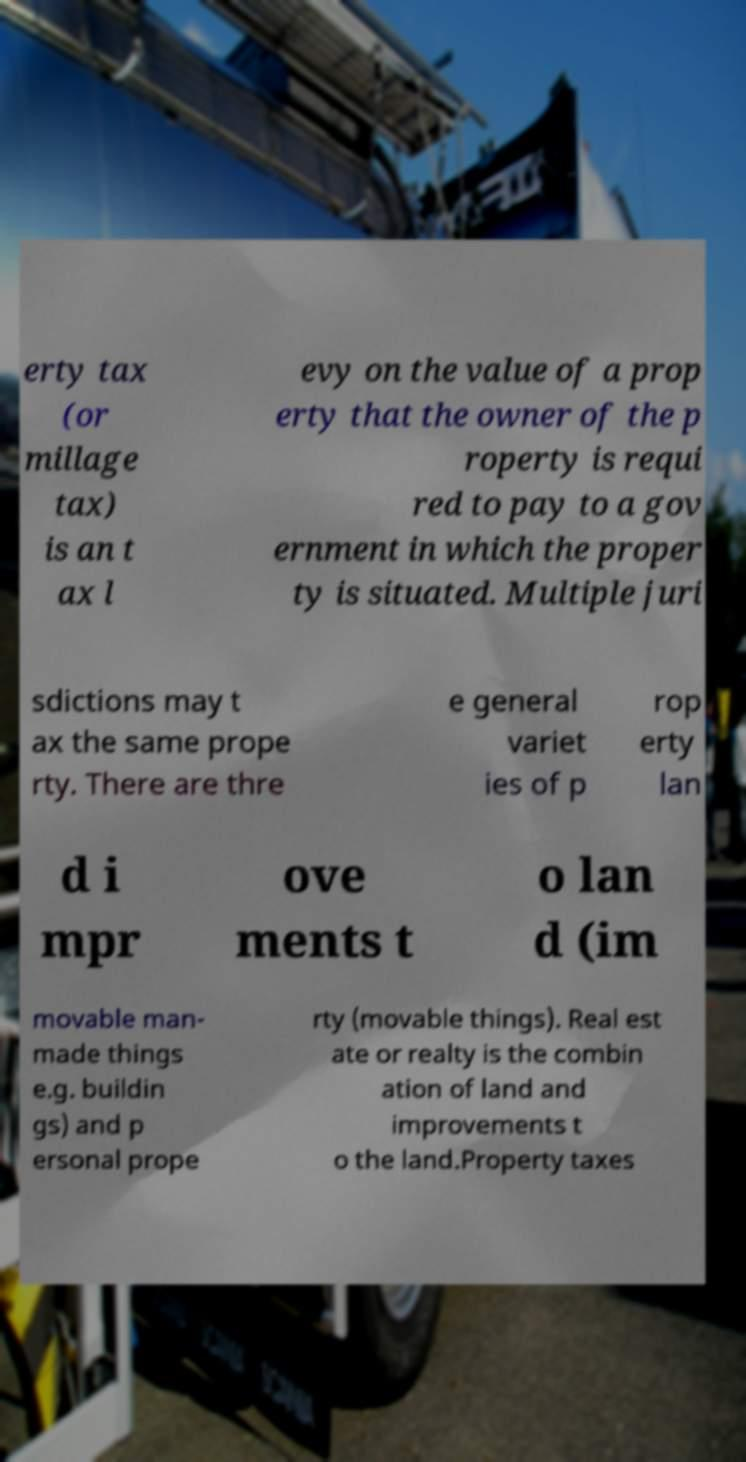Can you accurately transcribe the text from the provided image for me? erty tax (or millage tax) is an t ax l evy on the value of a prop erty that the owner of the p roperty is requi red to pay to a gov ernment in which the proper ty is situated. Multiple juri sdictions may t ax the same prope rty. There are thre e general variet ies of p rop erty lan d i mpr ove ments t o lan d (im movable man- made things e.g. buildin gs) and p ersonal prope rty (movable things). Real est ate or realty is the combin ation of land and improvements t o the land.Property taxes 